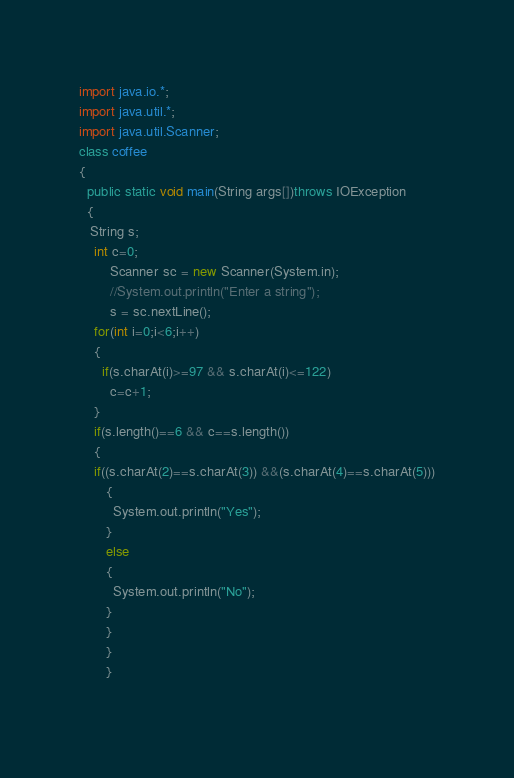<code> <loc_0><loc_0><loc_500><loc_500><_Java_>import java.io.*;
import java.util.*;
import java.util.Scanner;
class coffee
{
  public static void main(String args[])throws IOException
  {
   String s; 
    int c=0;
		Scanner sc = new Scanner(System.in);
 		//System.out.println("Enter a string"); 
 		s = sc.nextLine(); 
    for(int i=0;i<6;i++)
    {
      if(s.charAt(i)>=97 && s.charAt(i)<=122)
        c=c+1;
    }
    if(s.length()==6 && c==s.length())
    {
    if((s.charAt(2)==s.charAt(3)) &&(s.charAt(4)==s.charAt(5)))
       {
         System.out.println("Yes");
       }
       else
       {
         System.out.println("No");
       }
       }
       }
       }
                                                              
</code> 